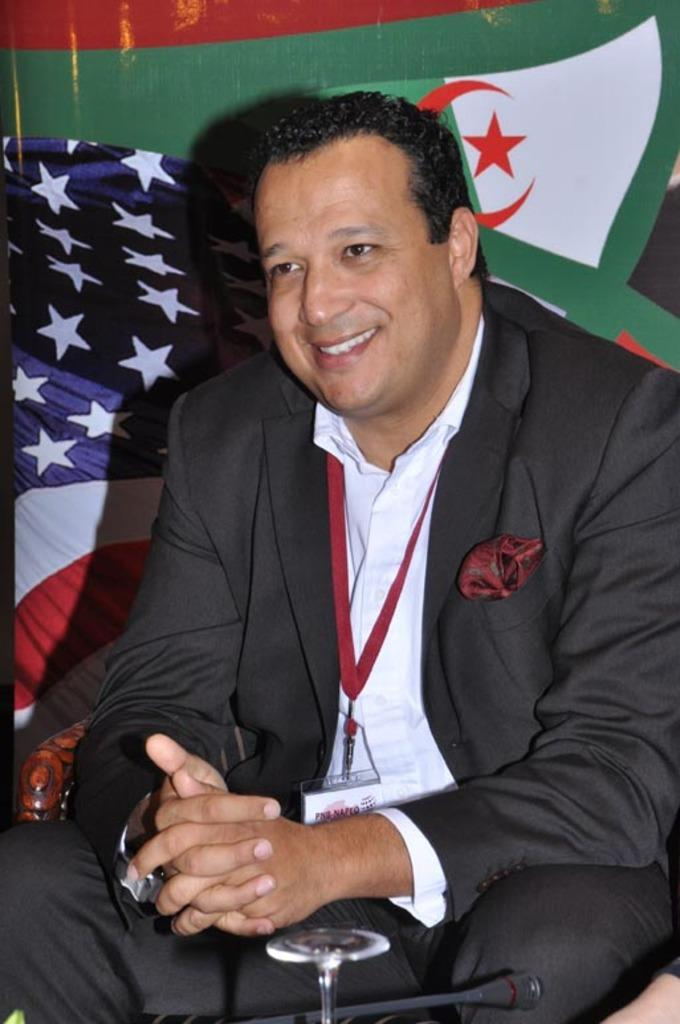What is the person in the image doing? The person is sitting on a chair in the image. What is the person's facial expression? The person is smiling. What is in front of the person? There is an object in front of the person. What can be seen behind the person? There is a flag visible behind the person. What type of curtain can be seen hanging from the grass in the image? There is no curtain or grass present in the image; it features a person sitting on a chair with a flag visible behind them. 